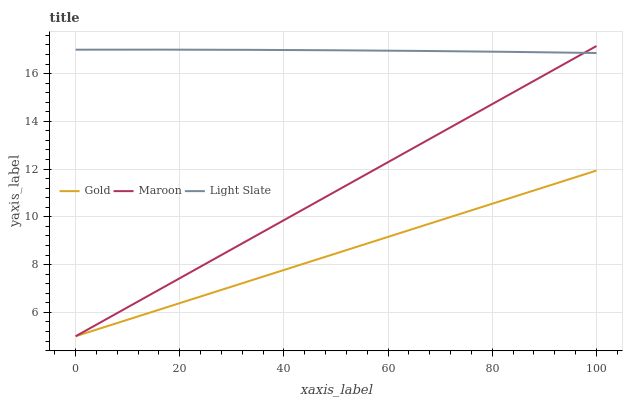Does Gold have the minimum area under the curve?
Answer yes or no. Yes. Does Light Slate have the maximum area under the curve?
Answer yes or no. Yes. Does Maroon have the minimum area under the curve?
Answer yes or no. No. Does Maroon have the maximum area under the curve?
Answer yes or no. No. Is Maroon the smoothest?
Answer yes or no. Yes. Is Light Slate the roughest?
Answer yes or no. Yes. Is Gold the smoothest?
Answer yes or no. No. Is Gold the roughest?
Answer yes or no. No. Does Maroon have the lowest value?
Answer yes or no. Yes. Does Maroon have the highest value?
Answer yes or no. Yes. Does Gold have the highest value?
Answer yes or no. No. Is Gold less than Light Slate?
Answer yes or no. Yes. Is Light Slate greater than Gold?
Answer yes or no. Yes. Does Maroon intersect Light Slate?
Answer yes or no. Yes. Is Maroon less than Light Slate?
Answer yes or no. No. Is Maroon greater than Light Slate?
Answer yes or no. No. Does Gold intersect Light Slate?
Answer yes or no. No. 